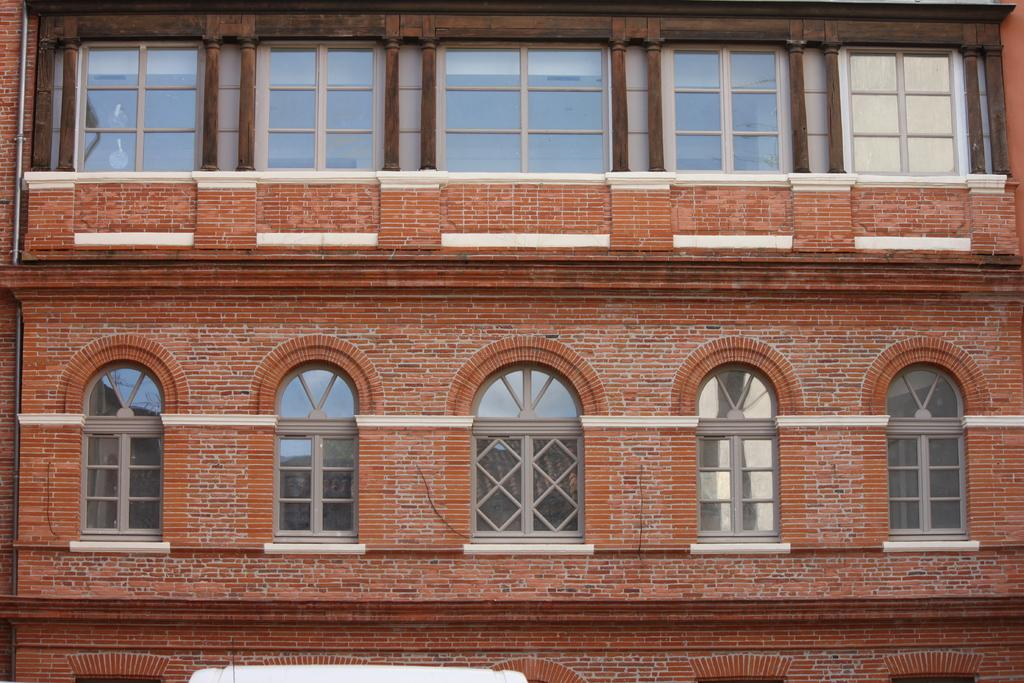What type of architectural feature can be seen in the image? There are windows visible in the image. What structure might the windows belong to? The windows belong to a building. What type of pets can be seen playing with a skateboard in the image? There are no pets or skateboards present in the image; it only features windows belonging to a building. 